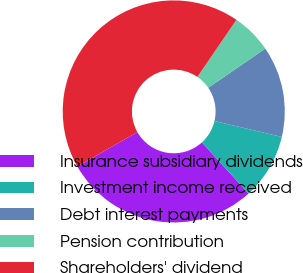<chart> <loc_0><loc_0><loc_500><loc_500><pie_chart><fcel>Insurance subsidiary dividends<fcel>Investment income received<fcel>Debt interest payments<fcel>Pension contribution<fcel>Shareholders' dividend<nl><fcel>28.52%<fcel>9.56%<fcel>13.26%<fcel>5.87%<fcel>42.79%<nl></chart> 